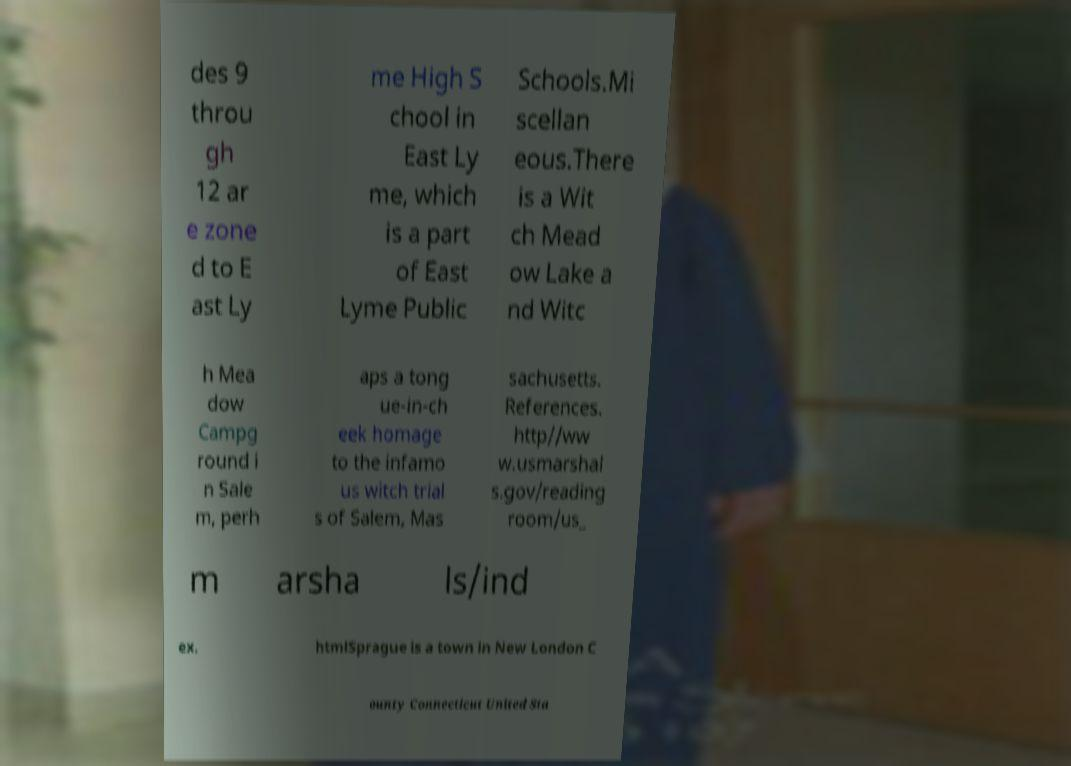Please read and relay the text visible in this image. What does it say? des 9 throu gh 12 ar e zone d to E ast Ly me High S chool in East Ly me, which is a part of East Lyme Public Schools.Mi scellan eous.There is a Wit ch Mead ow Lake a nd Witc h Mea dow Campg round i n Sale m, perh aps a tong ue-in-ch eek homage to the infamo us witch trial s of Salem, Mas sachusetts. References. http//ww w.usmarshal s.gov/reading room/us_ m arsha ls/ind ex. htmlSprague is a town in New London C ounty Connecticut United Sta 